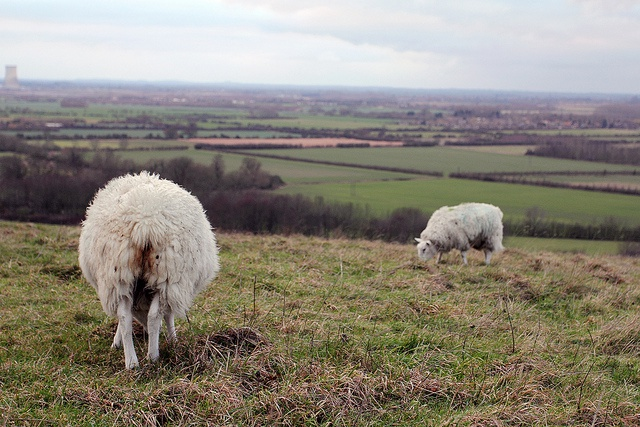Describe the objects in this image and their specific colors. I can see sheep in white, darkgray, and lightgray tones and sheep in white, darkgray, gray, and lightgray tones in this image. 